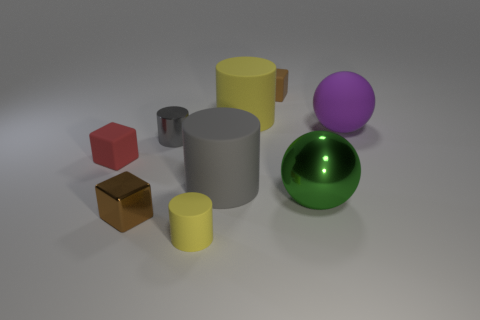Subtract 1 cylinders. How many cylinders are left? 3 Subtract all cylinders. How many objects are left? 5 Add 7 purple matte spheres. How many purple matte spheres exist? 8 Subtract 0 cyan cubes. How many objects are left? 9 Subtract all big green objects. Subtract all shiny balls. How many objects are left? 7 Add 3 big green metallic objects. How many big green metallic objects are left? 4 